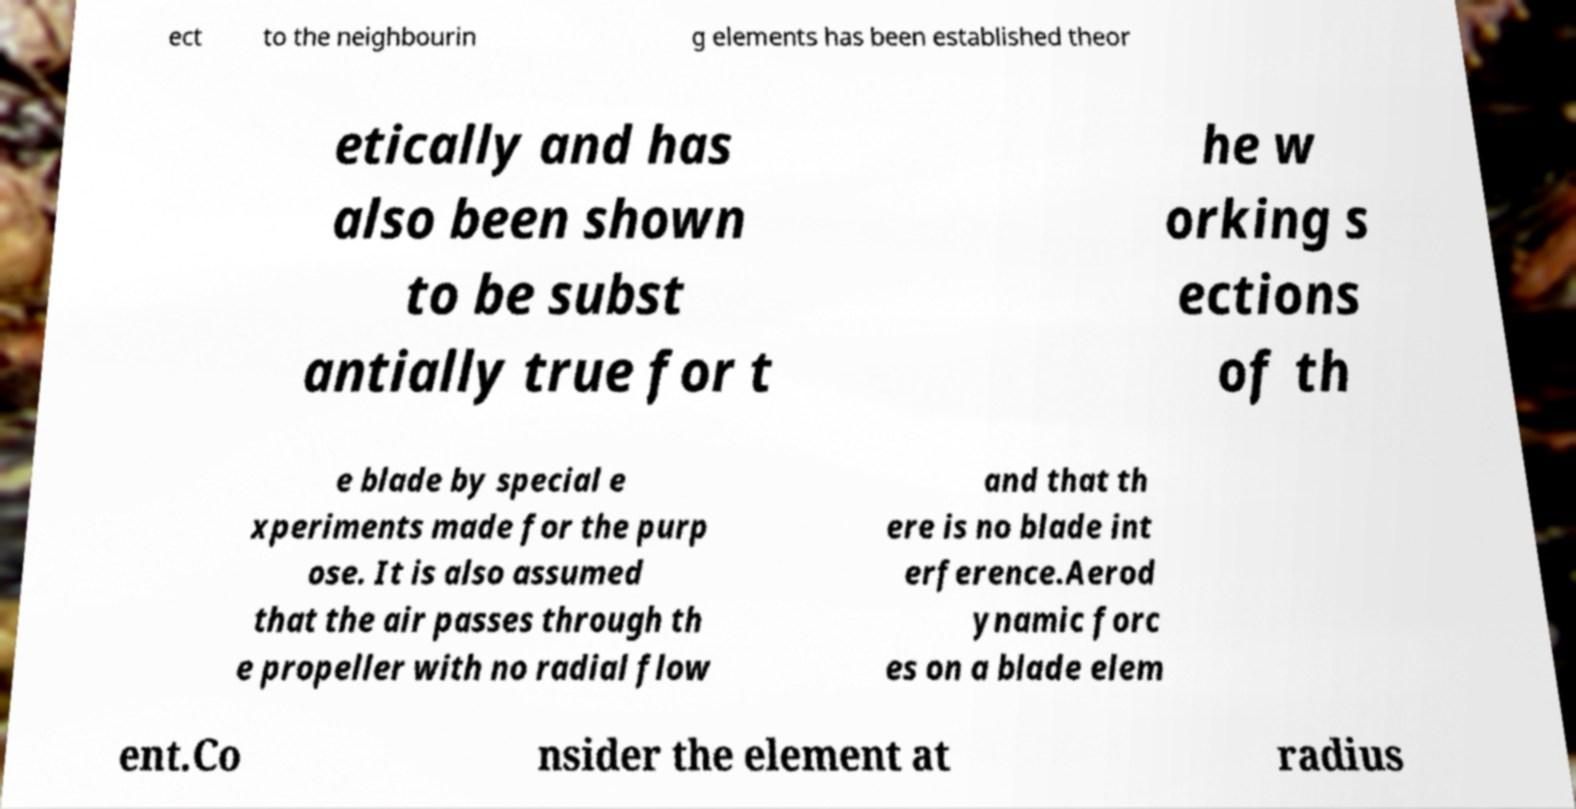For documentation purposes, I need the text within this image transcribed. Could you provide that? ect to the neighbourin g elements has been established theor etically and has also been shown to be subst antially true for t he w orking s ections of th e blade by special e xperiments made for the purp ose. It is also assumed that the air passes through th e propeller with no radial flow and that th ere is no blade int erference.Aerod ynamic forc es on a blade elem ent.Co nsider the element at radius 